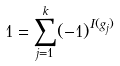Convert formula to latex. <formula><loc_0><loc_0><loc_500><loc_500>1 = \sum _ { j = 1 } ^ { k } ( - 1 ) ^ { I ( g _ { j } ) }</formula> 